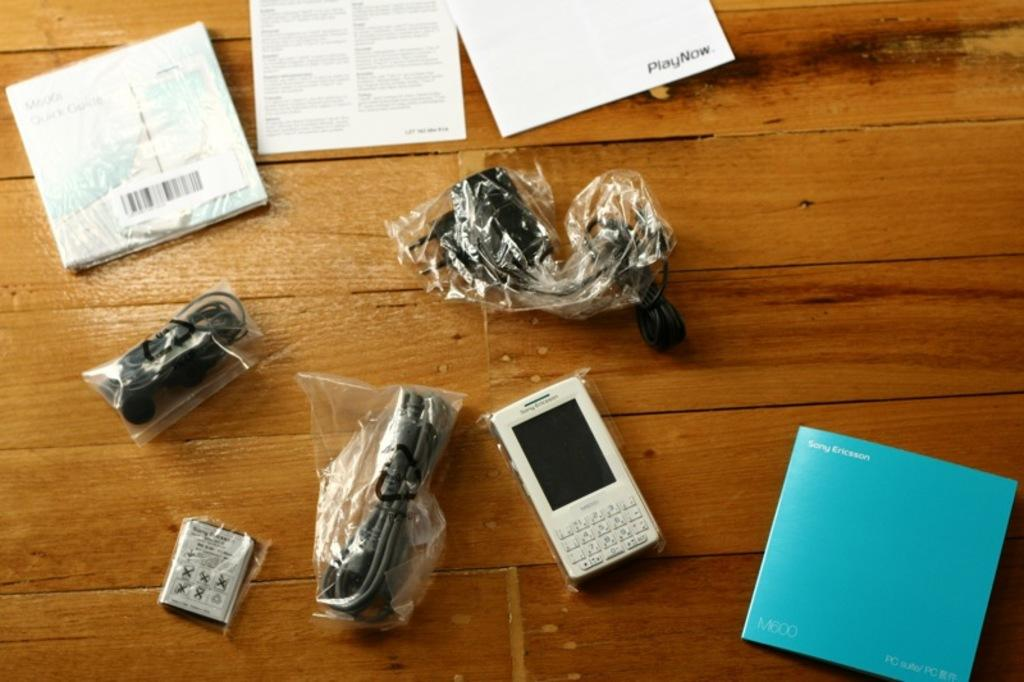<image>
Offer a succinct explanation of the picture presented. A Sony Ericsson sits on wood surface with cables still wrapped in plastic and the manual beside it. 